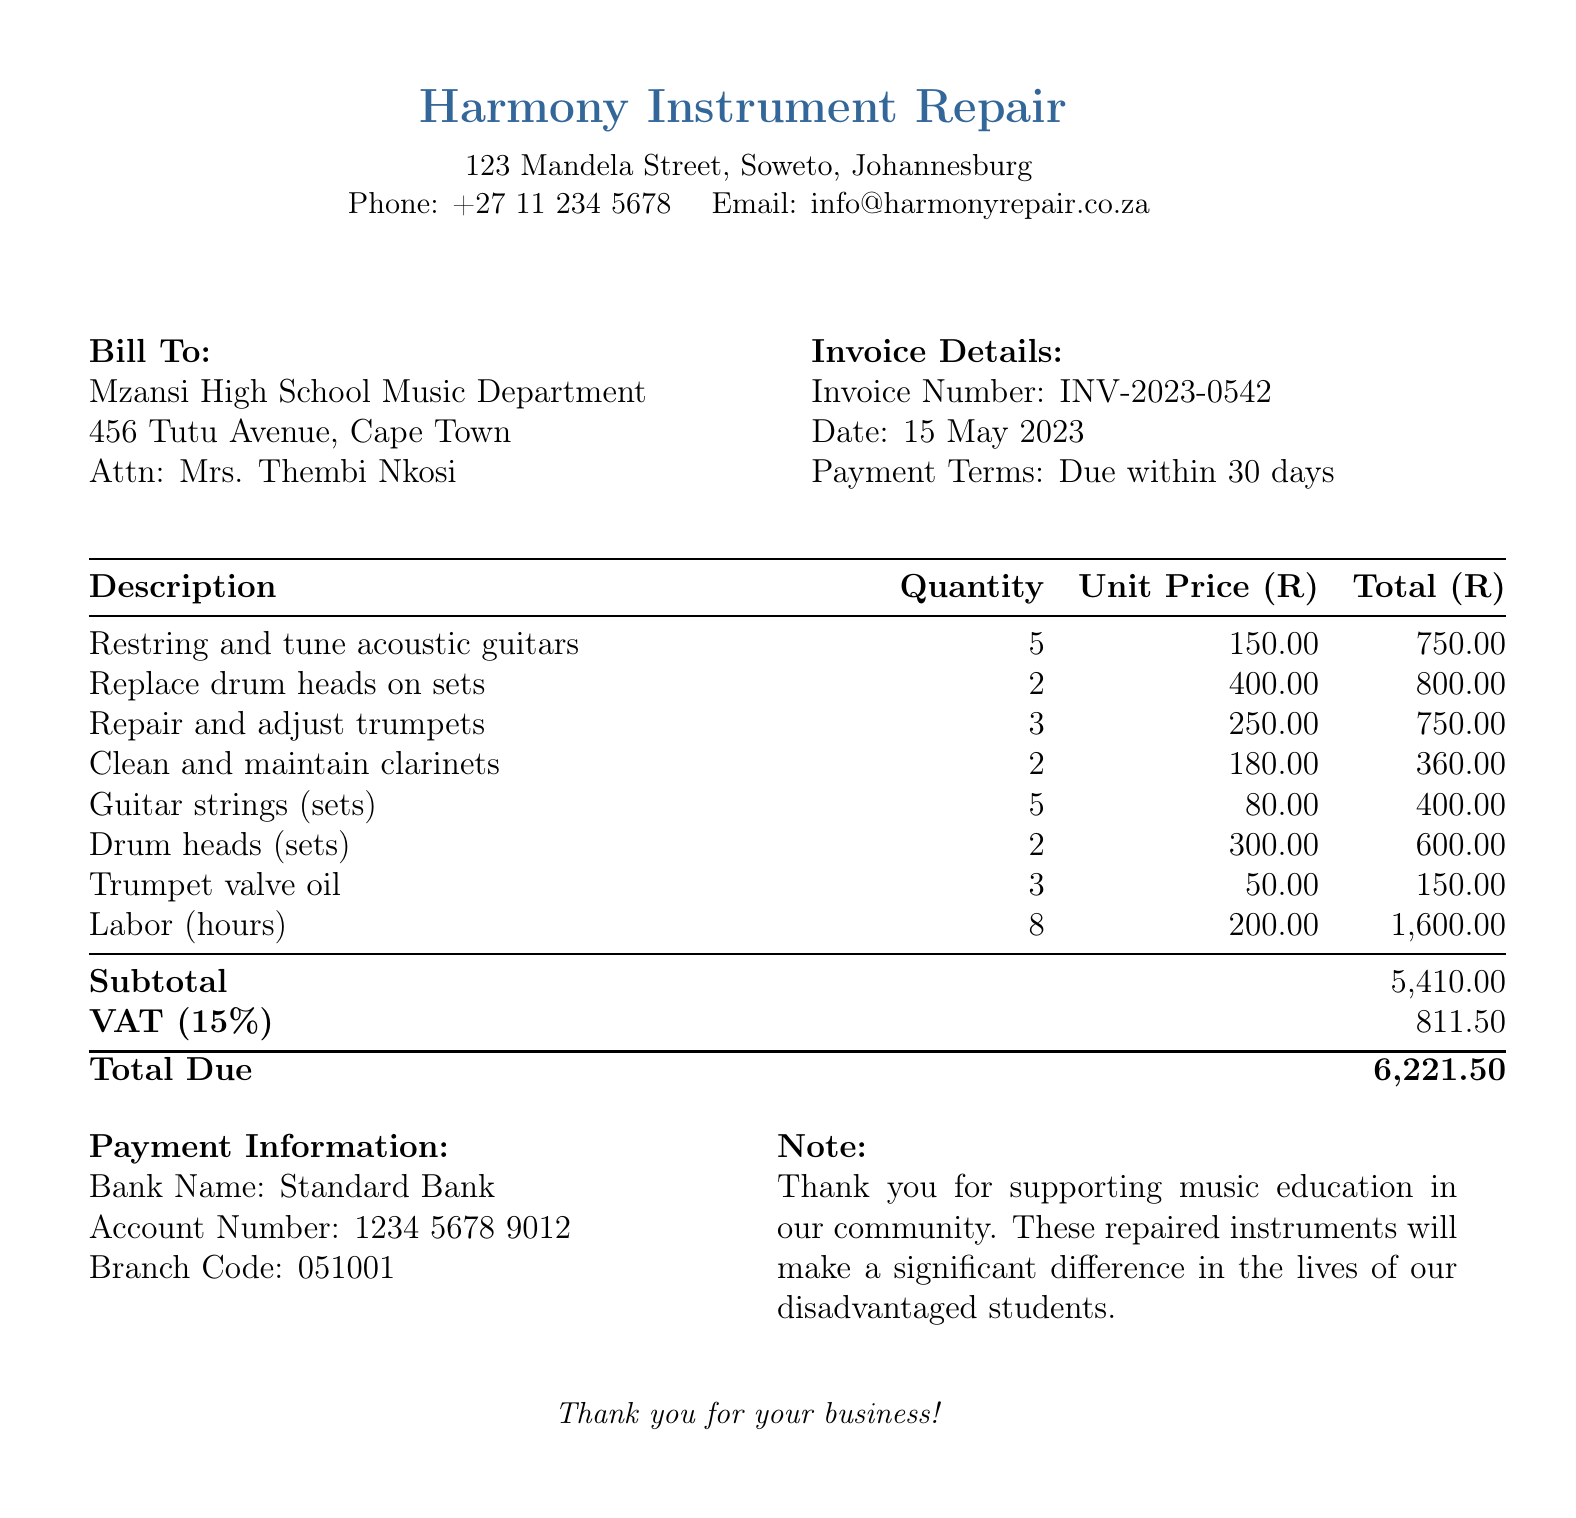What is the invoice number? The invoice number is listed in the "Invoice Details" section of the document.
Answer: INV-2023-0542 What is the total amount due? The total amount due is calculated by summing the subtotal and VAT, found at the bottom of the invoice.
Answer: 6,221.50 How many acoustic guitars were repaired? The "Description" section lists the quantity of acoustic guitars that were repaired.
Answer: 5 What date was the invoice issued? The invoice date is mentioned in the "Invoice Details" section.
Answer: 15 May 2023 What is the VAT percentage applied to the invoice? The VAT percentage is explicitly mentioned next to the VAT calculation in the document.
Answer: 15% What is the subtotal before VAT? The subtotal is calculated from the total costs of services and items before VAT is added.
Answer: 5,410.00 How many hours were charged for labor? The "Description" section specifies the labor duration.
Answer: 8 What type of bank is listed for payment information? The bank name is given in the "Payment Information" section of the document.
Answer: Standard Bank What items were used in the repair of instruments? The "Description" section lists the different instruments and services provided in the bill.
Answer: Restring and tune acoustic guitars, replace drum heads on sets, repair and adjust trumpets, clean and maintain clarinets, guitar strings, drum heads, trumpet valve oil, labor 